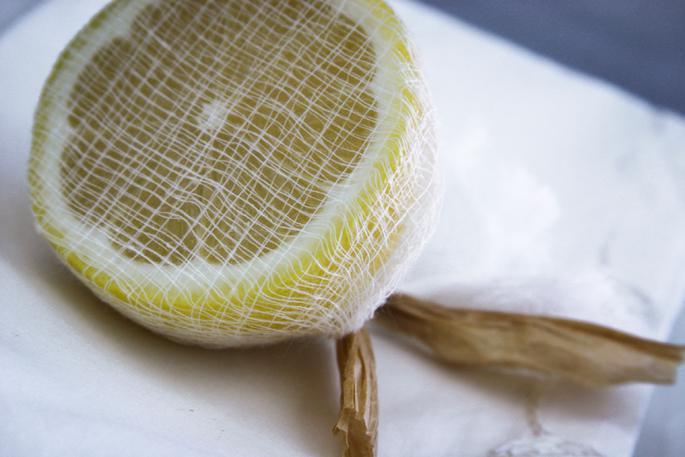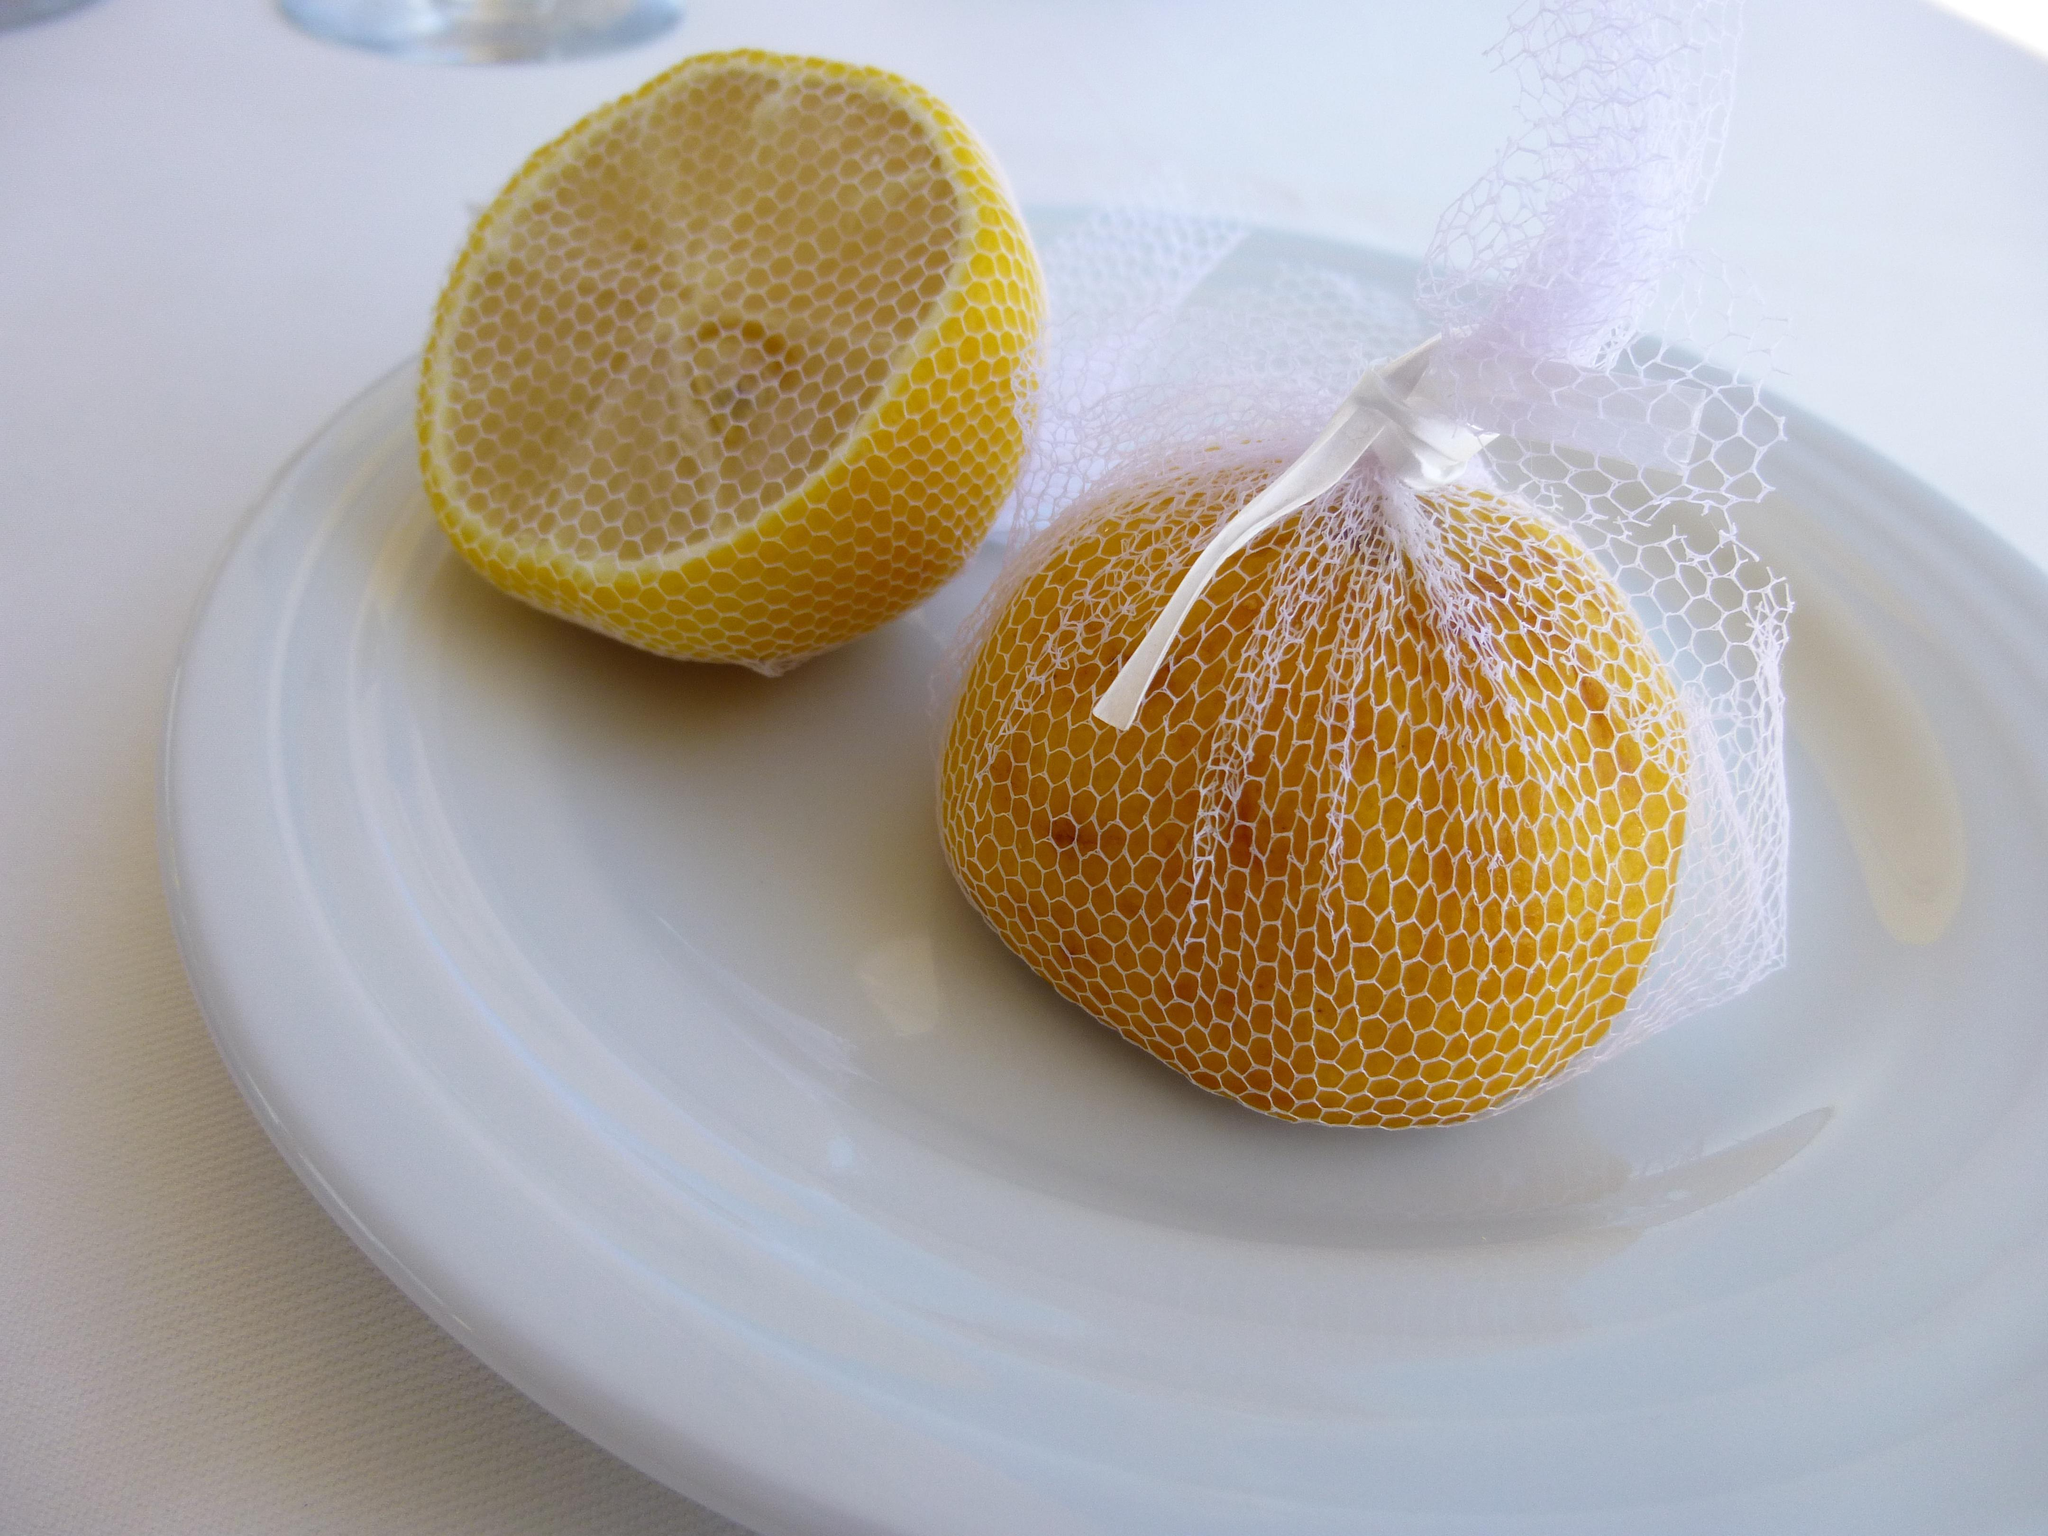The first image is the image on the left, the second image is the image on the right. For the images shown, is this caption "In at least one image there are two halves of a lemon." true? Answer yes or no. Yes. 